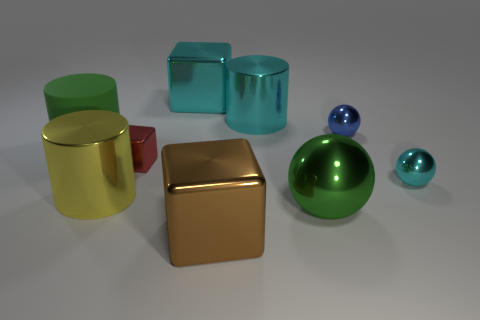Subtract all metal cylinders. How many cylinders are left? 1 Add 1 tiny yellow rubber cubes. How many objects exist? 10 Subtract all cyan cylinders. How many cylinders are left? 2 Subtract 2 cylinders. How many cylinders are left? 1 Subtract all cylinders. How many objects are left? 6 Subtract all red cubes. Subtract all large yellow metallic objects. How many objects are left? 7 Add 8 large yellow objects. How many large yellow objects are left? 9 Add 6 small shiny objects. How many small shiny objects exist? 9 Subtract 1 green spheres. How many objects are left? 8 Subtract all red balls. Subtract all yellow cubes. How many balls are left? 3 